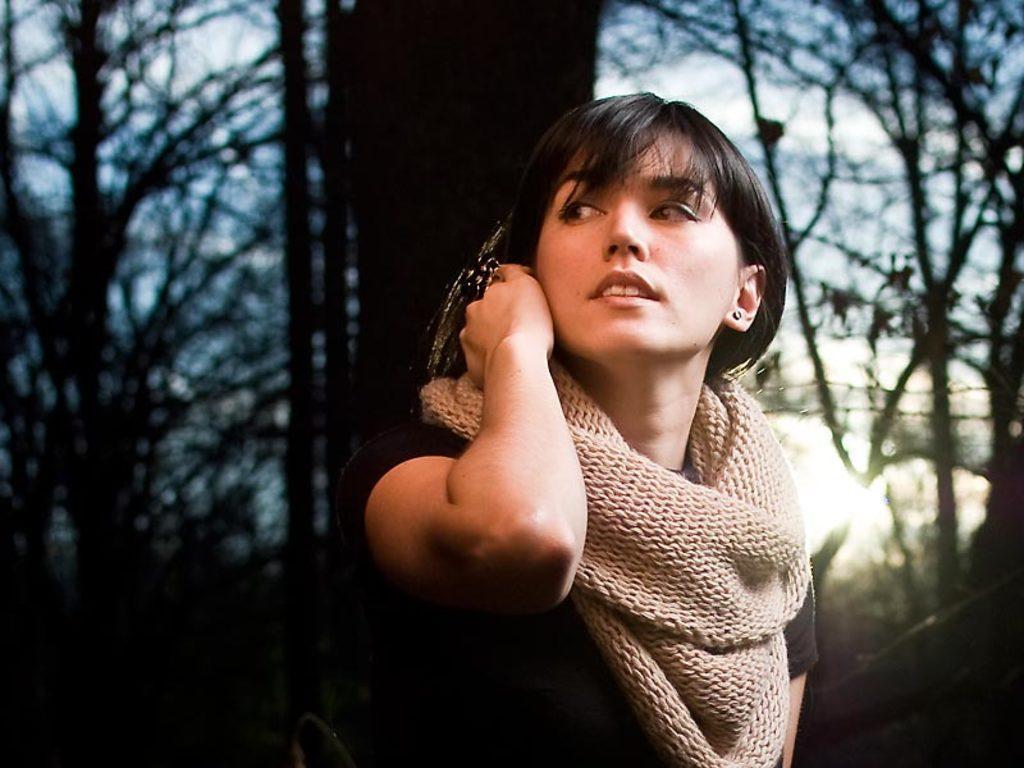How would you summarize this image in a sentence or two? In the middle of this image, there is a woman having a scarf, smiling and watching something. In the background, there are trees, light and there are clouds in the sky. 